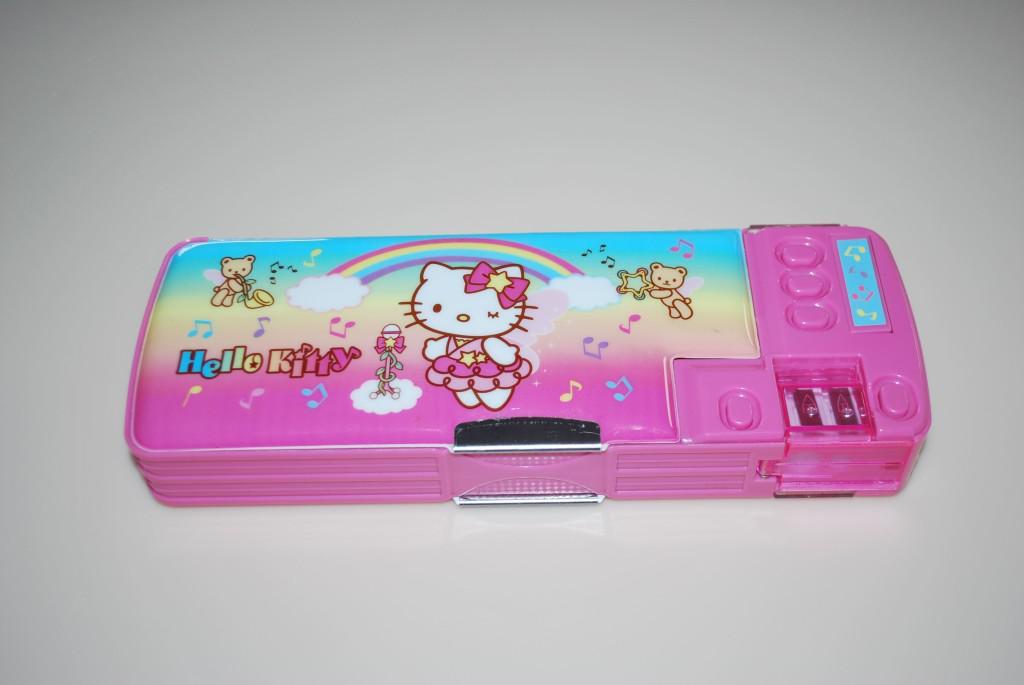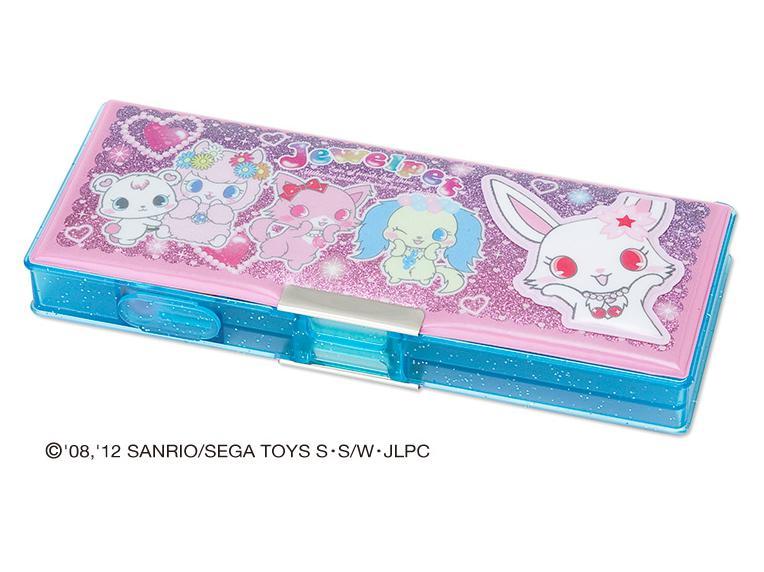The first image is the image on the left, the second image is the image on the right. Evaluate the accuracy of this statement regarding the images: "There are exactly two hard plastic pencil boxes that are both closed.". Is it true? Answer yes or no. Yes. 